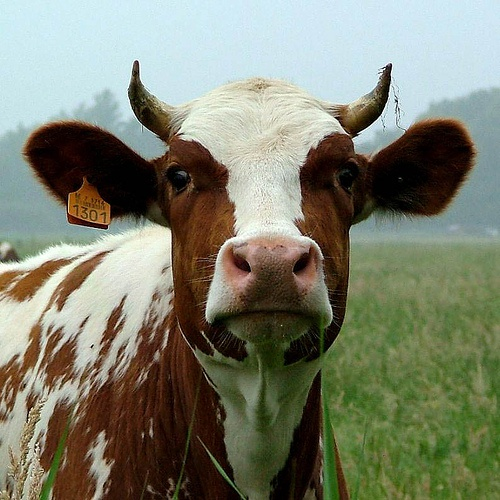Describe the objects in this image and their specific colors. I can see a cow in lightblue, black, beige, maroon, and olive tones in this image. 